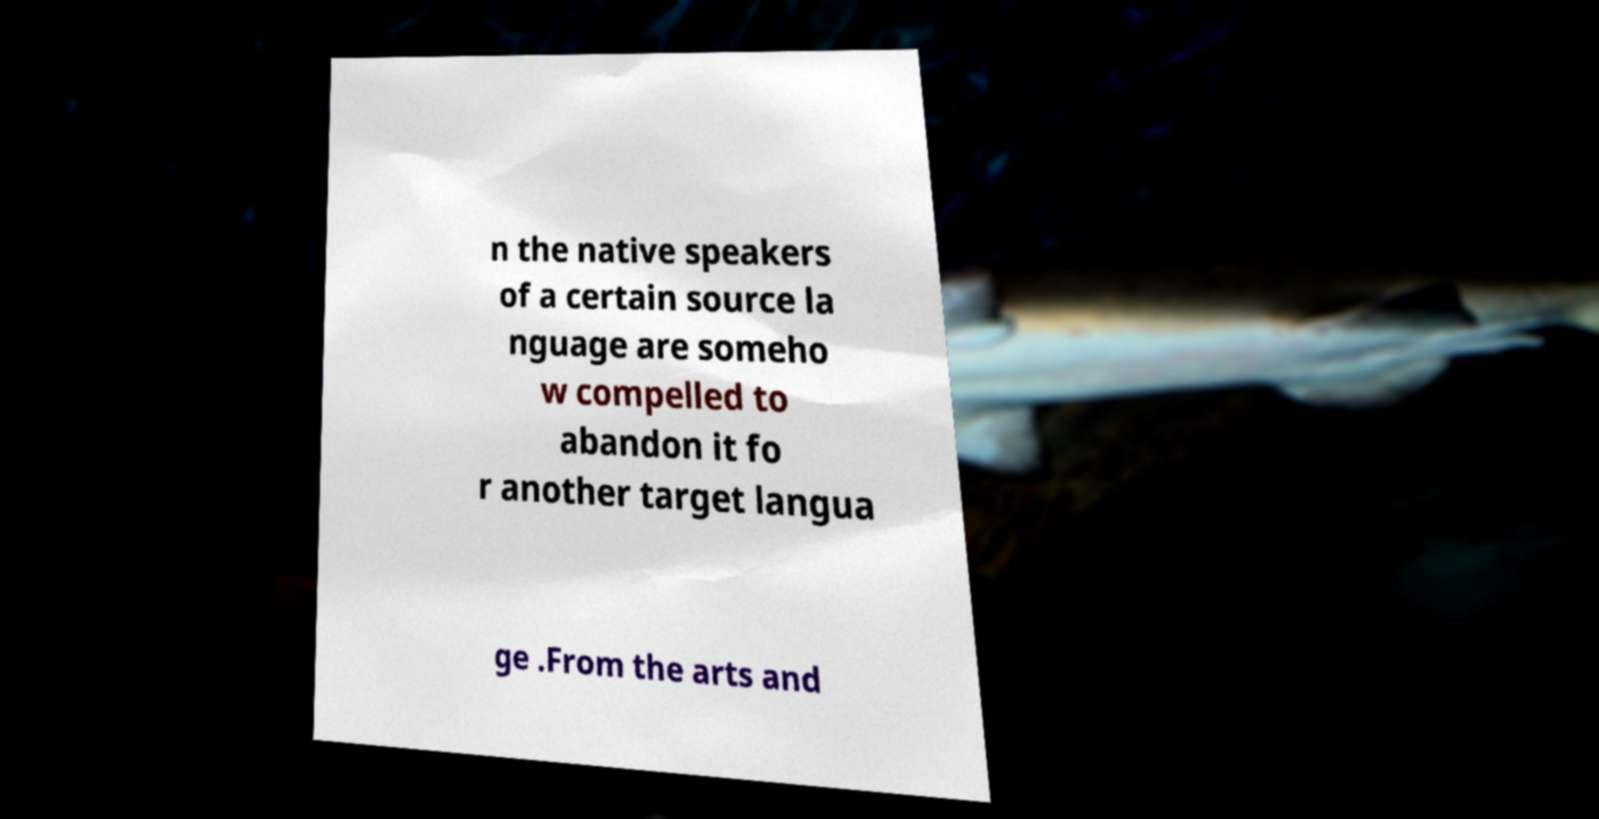Can you accurately transcribe the text from the provided image for me? n the native speakers of a certain source la nguage are someho w compelled to abandon it fo r another target langua ge .From the arts and 